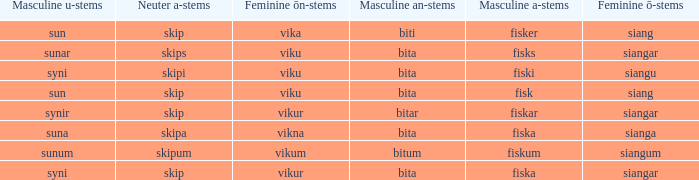What is the masculine u form for the old Swedish word with a neuter a form of skipum? Sunum. 